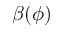Convert formula to latex. <formula><loc_0><loc_0><loc_500><loc_500>\beta ( \phi )</formula> 